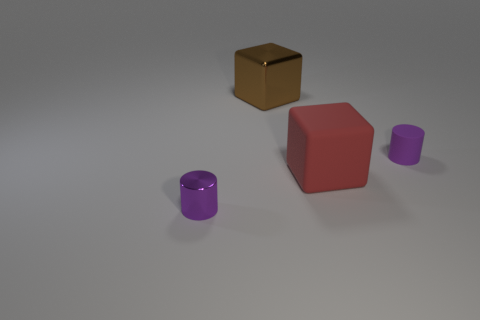Subtract all red cubes. Subtract all green balls. How many cubes are left? 1 Add 1 brown shiny cubes. How many objects exist? 5 Add 3 small metal cylinders. How many small metal cylinders are left? 4 Add 3 small cyan shiny cylinders. How many small cyan shiny cylinders exist? 3 Subtract 0 yellow cylinders. How many objects are left? 4 Subtract all purple matte balls. Subtract all big red things. How many objects are left? 3 